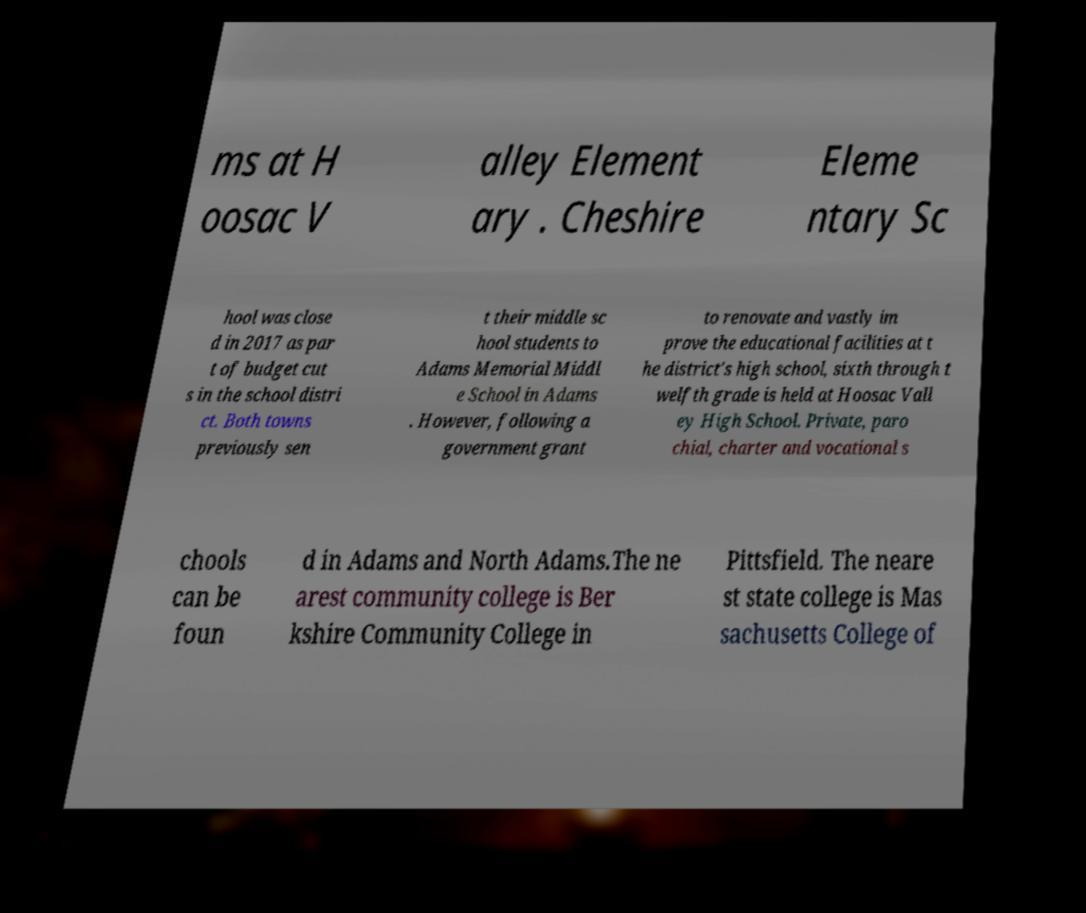Could you extract and type out the text from this image? ms at H oosac V alley Element ary . Cheshire Eleme ntary Sc hool was close d in 2017 as par t of budget cut s in the school distri ct. Both towns previously sen t their middle sc hool students to Adams Memorial Middl e School in Adams . However, following a government grant to renovate and vastly im prove the educational facilities at t he district's high school, sixth through t welfth grade is held at Hoosac Vall ey High School. Private, paro chial, charter and vocational s chools can be foun d in Adams and North Adams.The ne arest community college is Ber kshire Community College in Pittsfield. The neare st state college is Mas sachusetts College of 